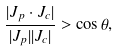Convert formula to latex. <formula><loc_0><loc_0><loc_500><loc_500>\frac { | J _ { p } \cdot J _ { c } | } { | J _ { p } | | J _ { c } | } > \cos \theta ,</formula> 